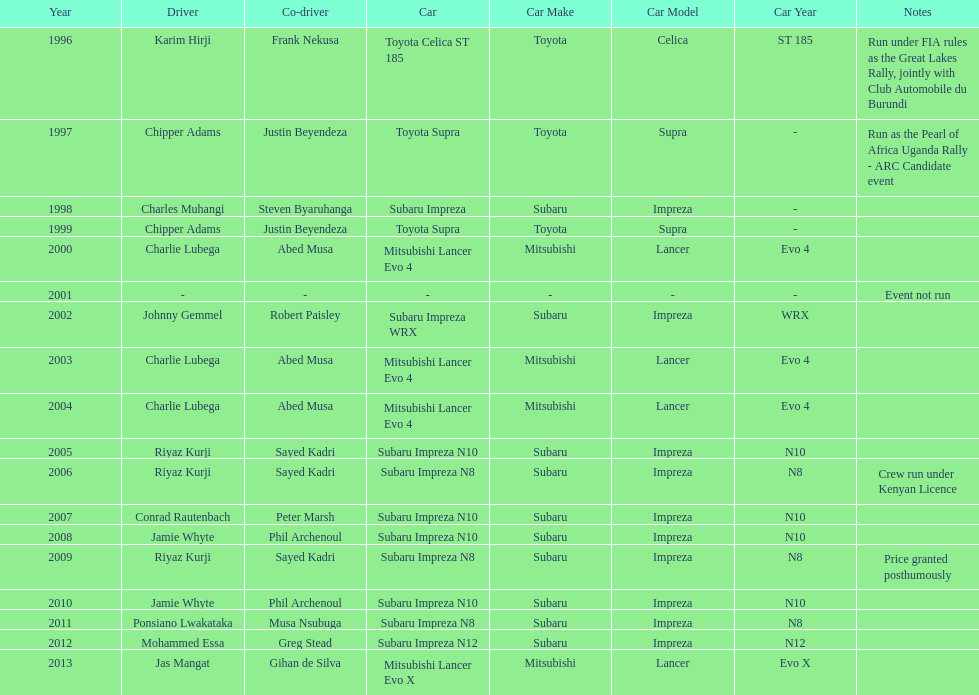How many drivers are racing with a co-driver from a different country? 1. 